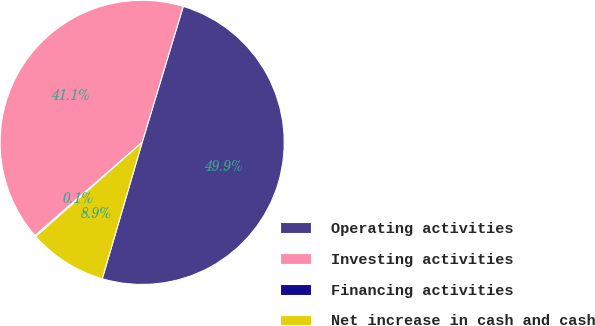<chart> <loc_0><loc_0><loc_500><loc_500><pie_chart><fcel>Operating activities<fcel>Investing activities<fcel>Financing activities<fcel>Net increase in cash and cash<nl><fcel>49.86%<fcel>41.06%<fcel>0.14%<fcel>8.94%<nl></chart> 